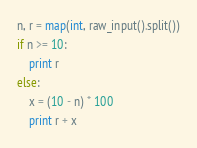<code> <loc_0><loc_0><loc_500><loc_500><_Python_>n, r = map(int, raw_input().split())
if n >= 10:
    print r
else:
    x = (10 - n) * 100
    print r + x
</code> 